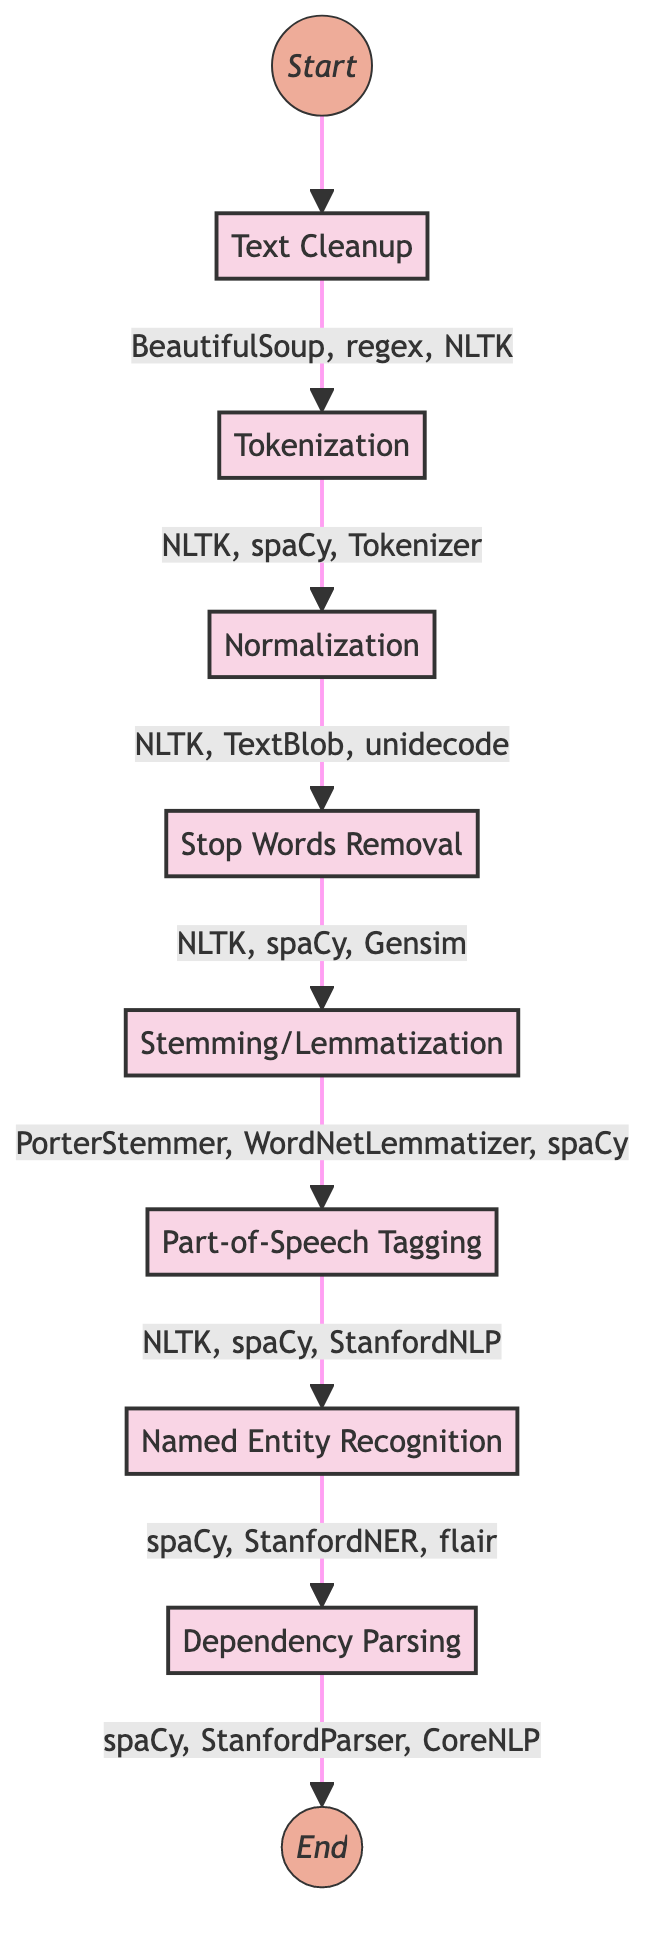What is the first step in the diagram? The diagram starts with the "Text Cleanup" step, which is the first node following the Start node marked as "Start".
Answer: Text Cleanup How many preprocessing steps are in the diagram? Counting all the steps from "Text Cleanup" to "Dependency Parsing", there are a total of 8 distinct steps in the processing flow.
Answer: 8 Which tool is associated with the "Normalization" step? The tools linked with "Normalization" as indicated in the diagram include "NLTK", "TextBlob", and "unidecode", which are mentioned right next to the corresponding node.
Answer: NLTK, TextBlob, unidecode What steps come after "Stop Words Removal"? Observing the flow of the diagram, the step that follows "Stop Words Removal" is "Stemming/Lemmatization" as indicated by the directional arrows between the nodes.
Answer: Stemming/Lemmatization What is the last step in the preprocessing steps? The last step in the diagram, marked by an arrow leading from the "Dependency Parsing" node, points to the final node labeled as "End".
Answer: End Which step comes before "Named Entity Recognition"? The diagram indicates that "Part-of-Speech Tagging" is the direct predecessor to "Named Entity Recognition", as evidenced by the connection between these two steps.
Answer: Part-of-Speech Tagging Which tool is used for "Text Cleanup"? The tools included in the "Text Cleanup" step are "BeautifulSoup", "regex", and "NLTK", showing the different options available for this phase of preprocessing.
Answer: BeautifulSoup, regex, NLTK Is "Tokenization" the last preprocessing step? The diagram displays the flow of steps, revealing that "Tokenization" is not the last step but occurs early in the process, specifically after "Text Cleanup".
Answer: No 